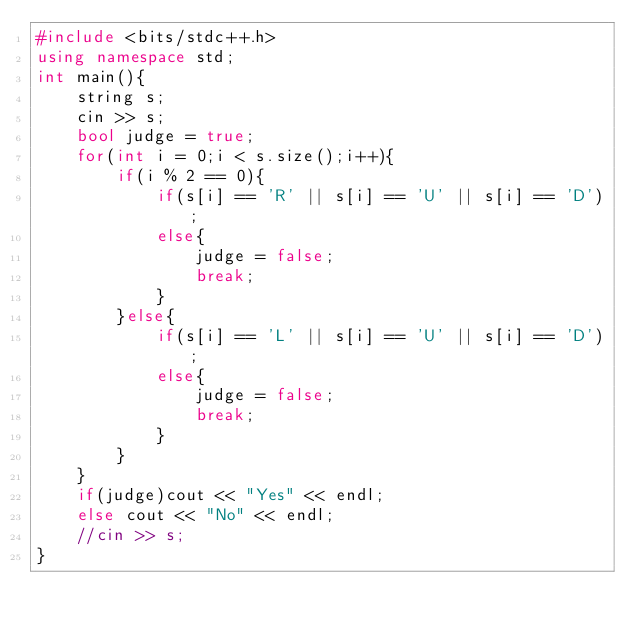Convert code to text. <code><loc_0><loc_0><loc_500><loc_500><_C++_>#include <bits/stdc++.h>
using namespace std;
int main(){
    string s;
    cin >> s;
    bool judge = true;
    for(int i = 0;i < s.size();i++){
        if(i % 2 == 0){
            if(s[i] == 'R' || s[i] == 'U' || s[i] == 'D');
            else{
                judge = false;
                break;
            }
        }else{
            if(s[i] == 'L' || s[i] == 'U' || s[i] == 'D');
            else{
                judge = false;
                break;
            }
        }
    }
    if(judge)cout << "Yes" << endl;
    else cout << "No" << endl;
    //cin >> s;
}
</code> 